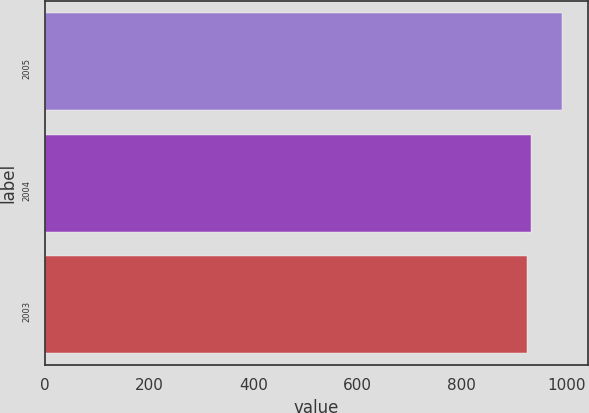<chart> <loc_0><loc_0><loc_500><loc_500><bar_chart><fcel>2005<fcel>2004<fcel>2003<nl><fcel>992.1<fcel>932.34<fcel>925.7<nl></chart> 